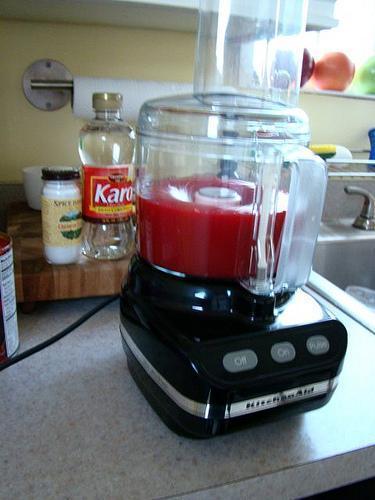How many bottles are visible?
Give a very brief answer. 2. 